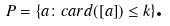Convert formula to latex. <formula><loc_0><loc_0><loc_500><loc_500>P = \{ a \colon c a r d ( [ a ] ) \leq k \} \text {.}</formula> 